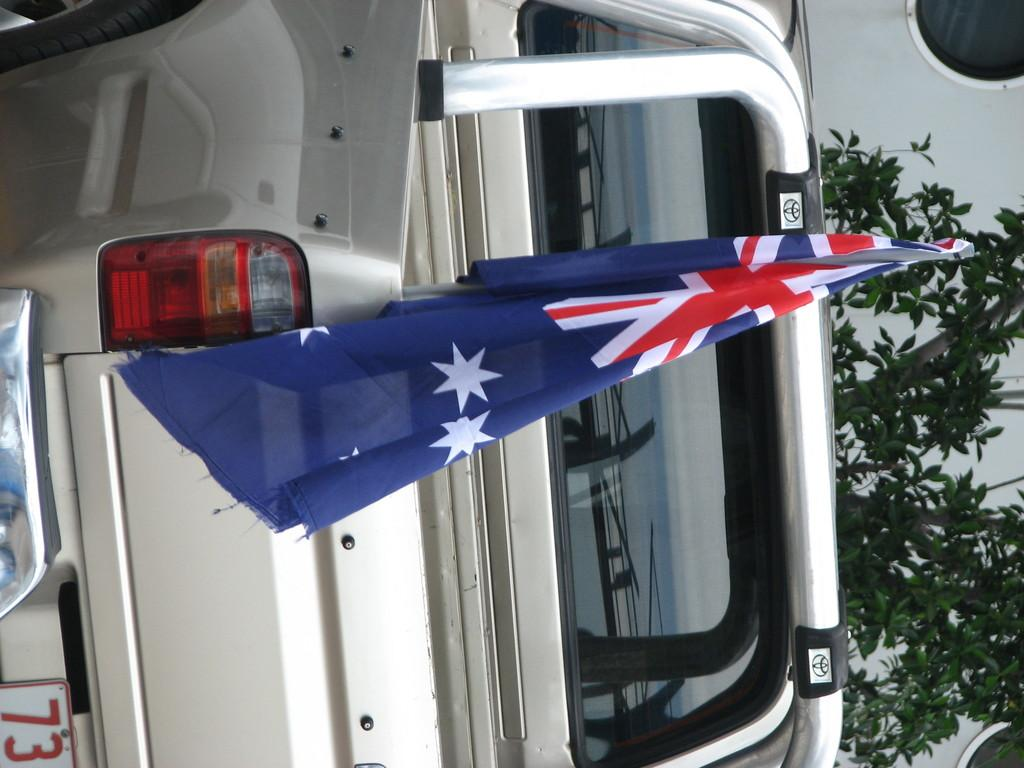What is the main subject in the image? There is a vehicle in the image. Are there any other notable objects or features in the image? Yes, there is a flag in the image, as well as plants on the right side. Can you describe the object in the background? There is an object in the background that appears to be a vehicle. What type of hammer is being used to knit a sweater in the mine in the image? There is no hammer, sweater, or mine present in the image. 